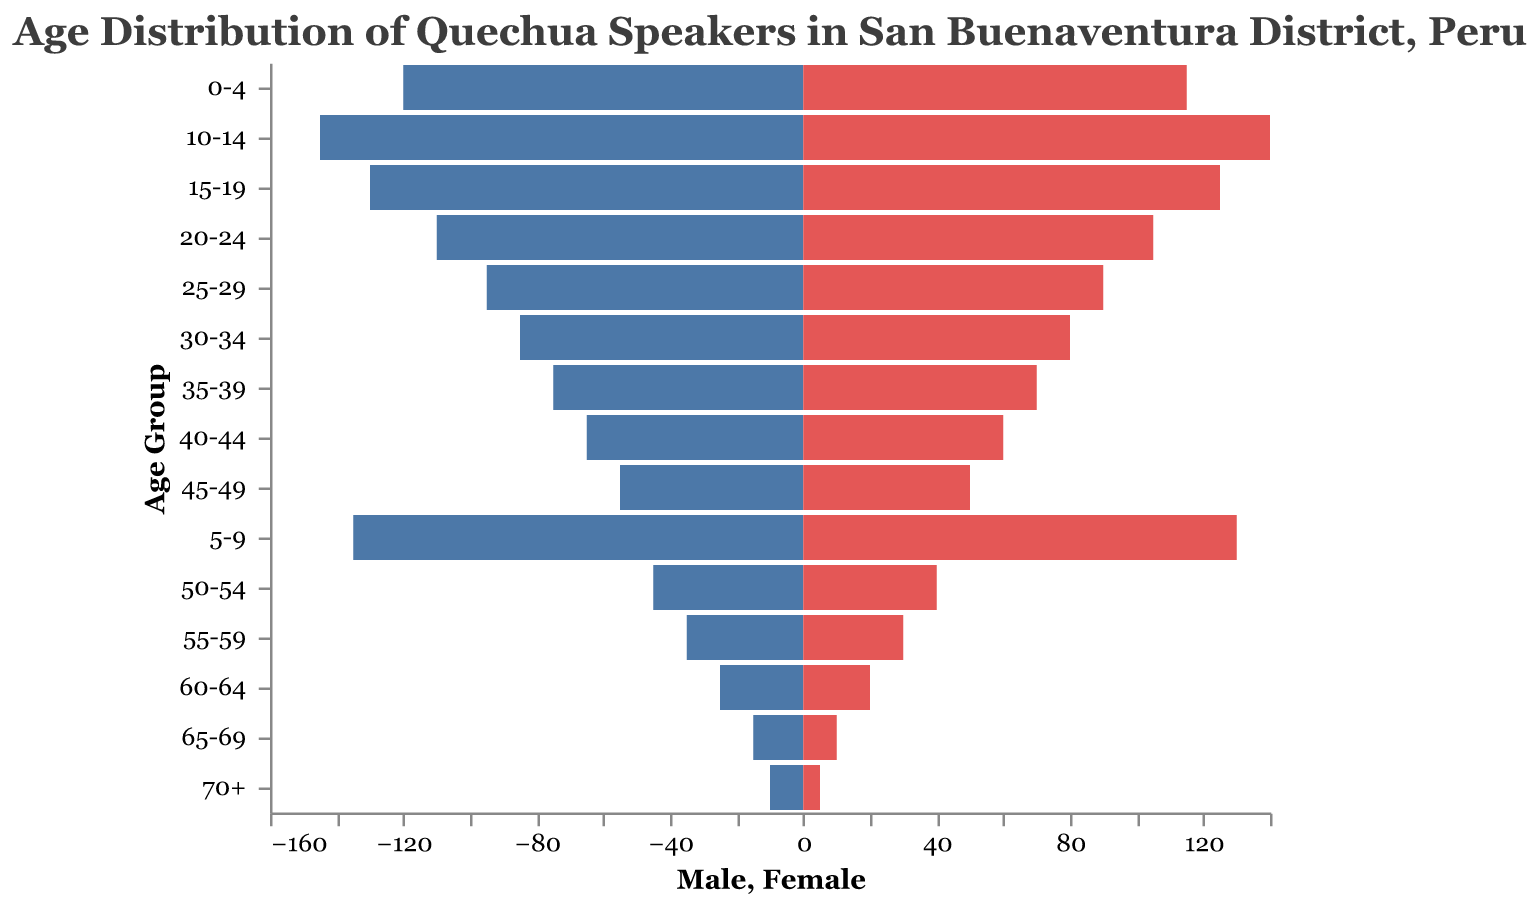What is the title of the figure? The title is usually displayed at the top of the figure, summarizing the main focus of the visualized data. In this case, the title is "Age Distribution of Quechua Speakers in San Buenaventura District, Peru".
Answer: Age Distribution of Quechua Speakers in San Buenaventura District, Peru Which age group has the highest number of males? To determine this, look at the bar lengths for the male population in each age group. The longest bar corresponds to the age group 10-14 with 145 males.
Answer: 10-14 What is the difference in the number of females between the 5-9 and 30-34 age groups? From the figure, the number of females in the 5-9 age group is 130 and in the 30-34 age group is 80. The difference is calculated as 130 - 80.
Answer: 50 Between the age groups 50-54 and 55-59, which has a higher total population (male + female)? Add the number of males and females for each age group: for 50-54, (45 + 40) = 85; for 55-59, (35 + 30) = 65. The age group 50-54 has a higher total population.
Answer: 50-54 What is the ratio of males to females in the 20-24 age group? The number of males is 110 and the number of females is 105. The ratio of males to females is 110:105, which simplifies to 22:21.
Answer: 22:21 Which age group has the smallest number of females? Find the shortest bar in the female section of the pyramid. The age group 70+ has the smallest number of females with 5.
Answer: 70+ How does the number of males in the 25-29 age group compare to the number of females in the same group? Look at the lengths of the bars for the 25-29 age group. There are 95 males and 90 females, which shows that there are more males than females.
Answer: More males What is the total population of Quechua speakers aged 60 and above? Sum the populations for age groups 60-64, 65-69, and 70+: (25+20) + (15+10) + (10+5) = 75.
Answer: 75 By how much does the number of males in the age group 0-4 exceed the number of females? The number of males is 120 and the number of females is 115. The difference is 120 - 115.
Answer: 5 Which age group shows the most balanced gender distribution? Analyzing the differences between the male and female populations in each age group, the 15-19 age group comes close with males at 130 and females at 125, a difference of 5.
Answer: 15-19 